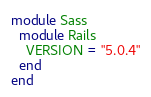<code> <loc_0><loc_0><loc_500><loc_500><_Ruby_>module Sass
  module Rails
    VERSION = "5.0.4"
  end
end
</code> 